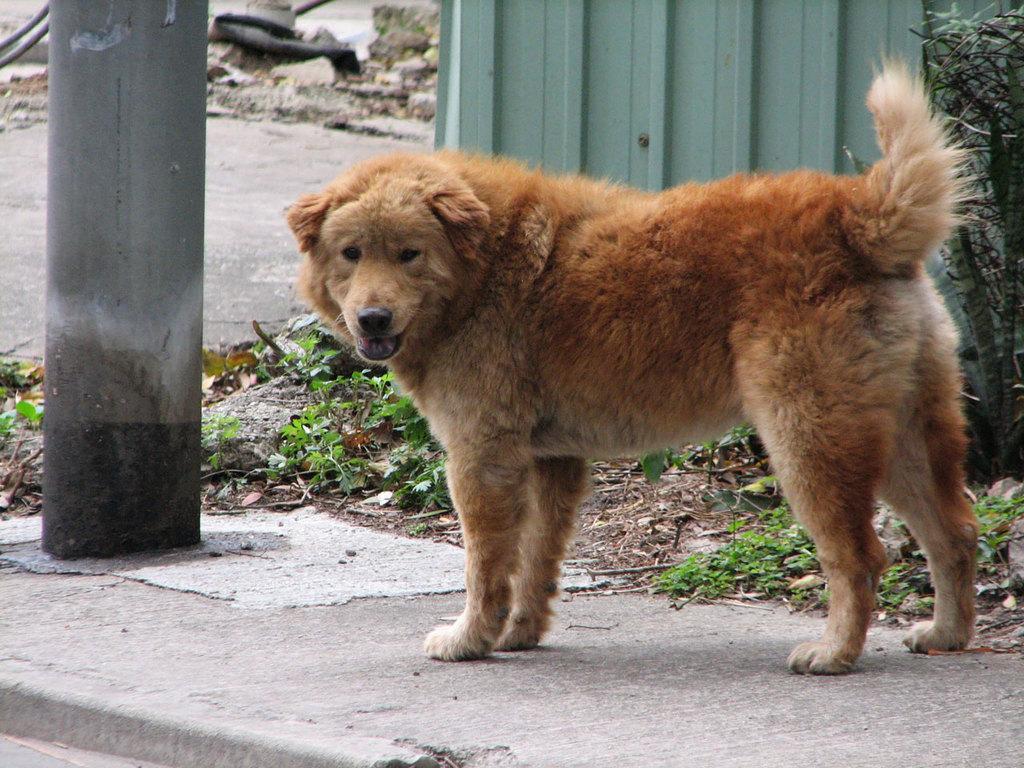Describe this image in one or two sentences. In this image we can see brown color dog is standing on the pavement. Background of the image, wall and metal sheet is there and we can see some leaves on the land. On the right side of the image, one plant is there. 